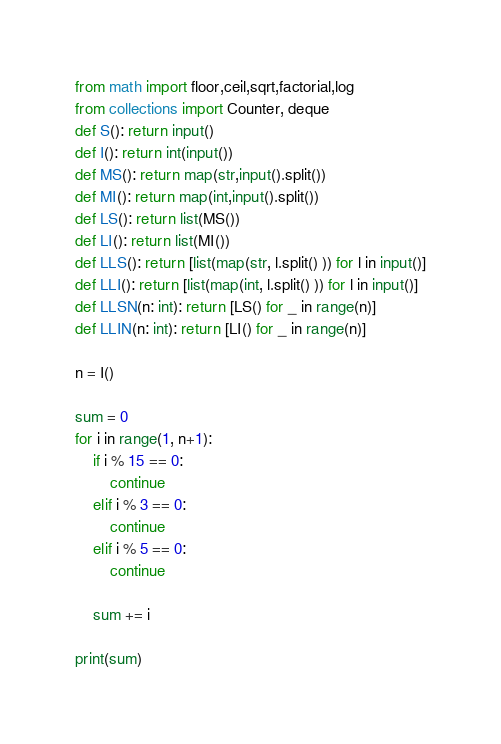Convert code to text. <code><loc_0><loc_0><loc_500><loc_500><_Python_>from math import floor,ceil,sqrt,factorial,log
from collections import Counter, deque
def S(): return input()
def I(): return int(input())
def MS(): return map(str,input().split())
def MI(): return map(int,input().split())
def LS(): return list(MS())
def LI(): return list(MI())
def LLS(): return [list(map(str, l.split() )) for l in input()]
def LLI(): return [list(map(int, l.split() )) for l in input()]
def LLSN(n: int): return [LS() for _ in range(n)]
def LLIN(n: int): return [LI() for _ in range(n)]

n = I()

sum = 0
for i in range(1, n+1):
    if i % 15 == 0:
        continue
    elif i % 3 == 0:
        continue
    elif i % 5 == 0:
        continue

    sum += i

print(sum)</code> 